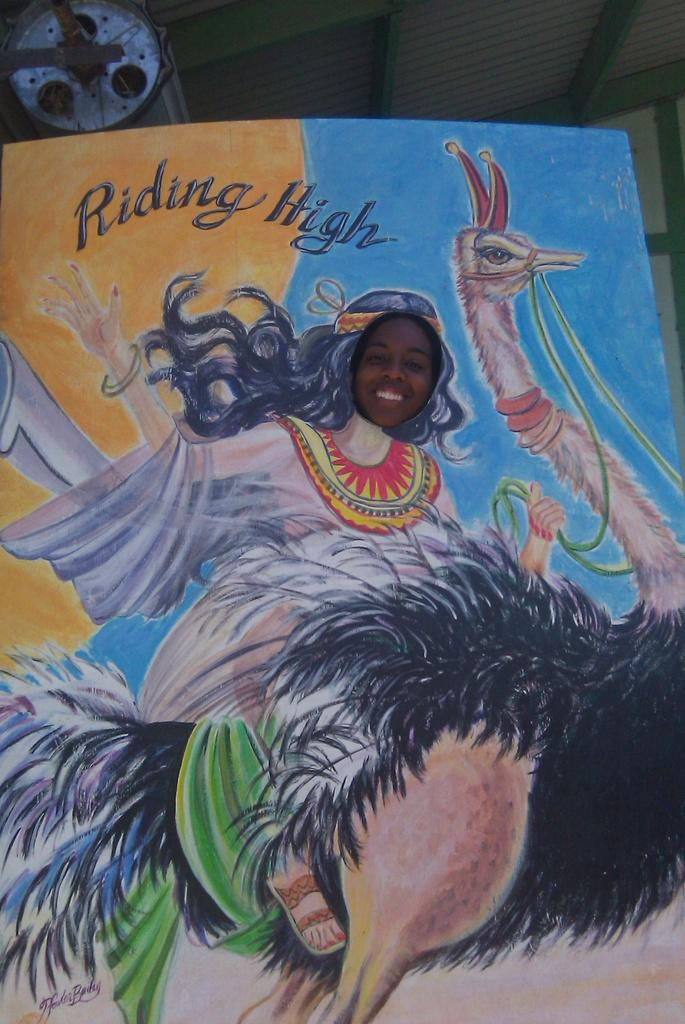What is the main subject of the poster in the image? The poster features a girl riding a black ostrich bird. Can you describe the quote on the poster? There is a small quote written on the poster. What year does the scene on the poster take place? The provided facts do not mention a specific year, so it is impossible to determine the year in which the scene takes place. 